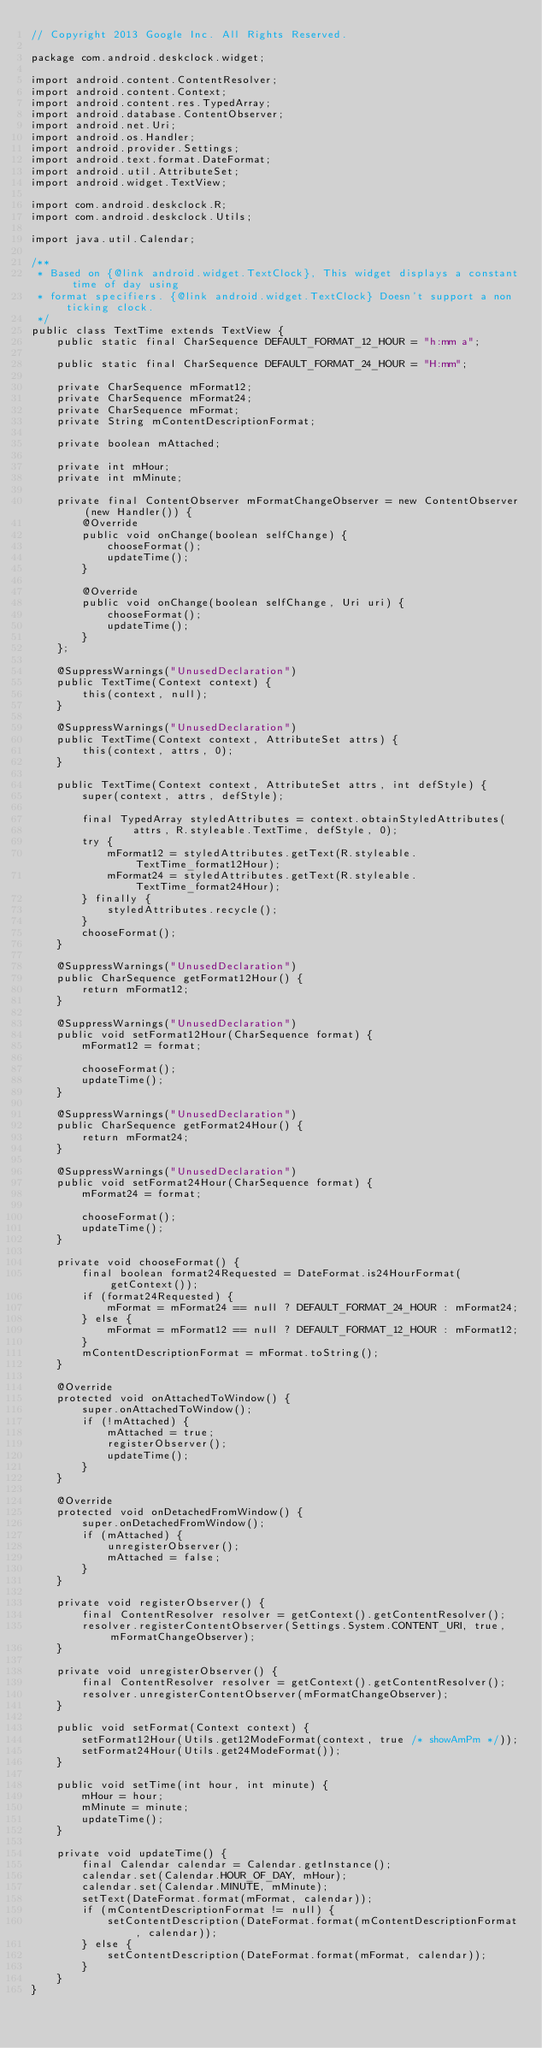Convert code to text. <code><loc_0><loc_0><loc_500><loc_500><_Java_>// Copyright 2013 Google Inc. All Rights Reserved.

package com.android.deskclock.widget;

import android.content.ContentResolver;
import android.content.Context;
import android.content.res.TypedArray;
import android.database.ContentObserver;
import android.net.Uri;
import android.os.Handler;
import android.provider.Settings;
import android.text.format.DateFormat;
import android.util.AttributeSet;
import android.widget.TextView;

import com.android.deskclock.R;
import com.android.deskclock.Utils;

import java.util.Calendar;

/**
 * Based on {@link android.widget.TextClock}, This widget displays a constant time of day using
 * format specifiers. {@link android.widget.TextClock} Doesn't support a non ticking clock.
 */
public class TextTime extends TextView {
    public static final CharSequence DEFAULT_FORMAT_12_HOUR = "h:mm a";

    public static final CharSequence DEFAULT_FORMAT_24_HOUR = "H:mm";

    private CharSequence mFormat12;
    private CharSequence mFormat24;
    private CharSequence mFormat;
    private String mContentDescriptionFormat;

    private boolean mAttached;

    private int mHour;
    private int mMinute;

    private final ContentObserver mFormatChangeObserver = new ContentObserver(new Handler()) {
        @Override
        public void onChange(boolean selfChange) {
            chooseFormat();
            updateTime();
        }

        @Override
        public void onChange(boolean selfChange, Uri uri) {
            chooseFormat();
            updateTime();
        }
    };

    @SuppressWarnings("UnusedDeclaration")
    public TextTime(Context context) {
        this(context, null);
    }

    @SuppressWarnings("UnusedDeclaration")
    public TextTime(Context context, AttributeSet attrs) {
        this(context, attrs, 0);
    }

    public TextTime(Context context, AttributeSet attrs, int defStyle) {
        super(context, attrs, defStyle);

        final TypedArray styledAttributes = context.obtainStyledAttributes(
                attrs, R.styleable.TextTime, defStyle, 0);
        try {
            mFormat12 = styledAttributes.getText(R.styleable.TextTime_format12Hour);
            mFormat24 = styledAttributes.getText(R.styleable.TextTime_format24Hour);
        } finally {
            styledAttributes.recycle();
        }
        chooseFormat();
    }

    @SuppressWarnings("UnusedDeclaration")
    public CharSequence getFormat12Hour() {
        return mFormat12;
    }

    @SuppressWarnings("UnusedDeclaration")
    public void setFormat12Hour(CharSequence format) {
        mFormat12 = format;

        chooseFormat();
        updateTime();
    }

    @SuppressWarnings("UnusedDeclaration")
    public CharSequence getFormat24Hour() {
        return mFormat24;
    }

    @SuppressWarnings("UnusedDeclaration")
    public void setFormat24Hour(CharSequence format) {
        mFormat24 = format;

        chooseFormat();
        updateTime();
    }

    private void chooseFormat() {
        final boolean format24Requested = DateFormat.is24HourFormat(getContext());
        if (format24Requested) {
            mFormat = mFormat24 == null ? DEFAULT_FORMAT_24_HOUR : mFormat24;
        } else {
            mFormat = mFormat12 == null ? DEFAULT_FORMAT_12_HOUR : mFormat12;
        }
        mContentDescriptionFormat = mFormat.toString();
    }

    @Override
    protected void onAttachedToWindow() {
        super.onAttachedToWindow();
        if (!mAttached) {
            mAttached = true;
            registerObserver();
            updateTime();
        }
    }

    @Override
    protected void onDetachedFromWindow() {
        super.onDetachedFromWindow();
        if (mAttached) {
            unregisterObserver();
            mAttached = false;
        }
    }

    private void registerObserver() {
        final ContentResolver resolver = getContext().getContentResolver();
        resolver.registerContentObserver(Settings.System.CONTENT_URI, true, mFormatChangeObserver);
    }

    private void unregisterObserver() {
        final ContentResolver resolver = getContext().getContentResolver();
        resolver.unregisterContentObserver(mFormatChangeObserver);
    }

    public void setFormat(Context context) {
        setFormat12Hour(Utils.get12ModeFormat(context, true /* showAmPm */));
        setFormat24Hour(Utils.get24ModeFormat());
    }

    public void setTime(int hour, int minute) {
        mHour = hour;
        mMinute = minute;
        updateTime();
    }

    private void updateTime() {
        final Calendar calendar = Calendar.getInstance();
        calendar.set(Calendar.HOUR_OF_DAY, mHour);
        calendar.set(Calendar.MINUTE, mMinute);
        setText(DateFormat.format(mFormat, calendar));
        if (mContentDescriptionFormat != null) {
            setContentDescription(DateFormat.format(mContentDescriptionFormat, calendar));
        } else {
            setContentDescription(DateFormat.format(mFormat, calendar));
        }
    }
}
</code> 